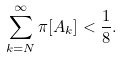<formula> <loc_0><loc_0><loc_500><loc_500>\sum _ { k = N } ^ { \infty } \pi [ A _ { k } ] < \frac { 1 } { 8 } .</formula> 